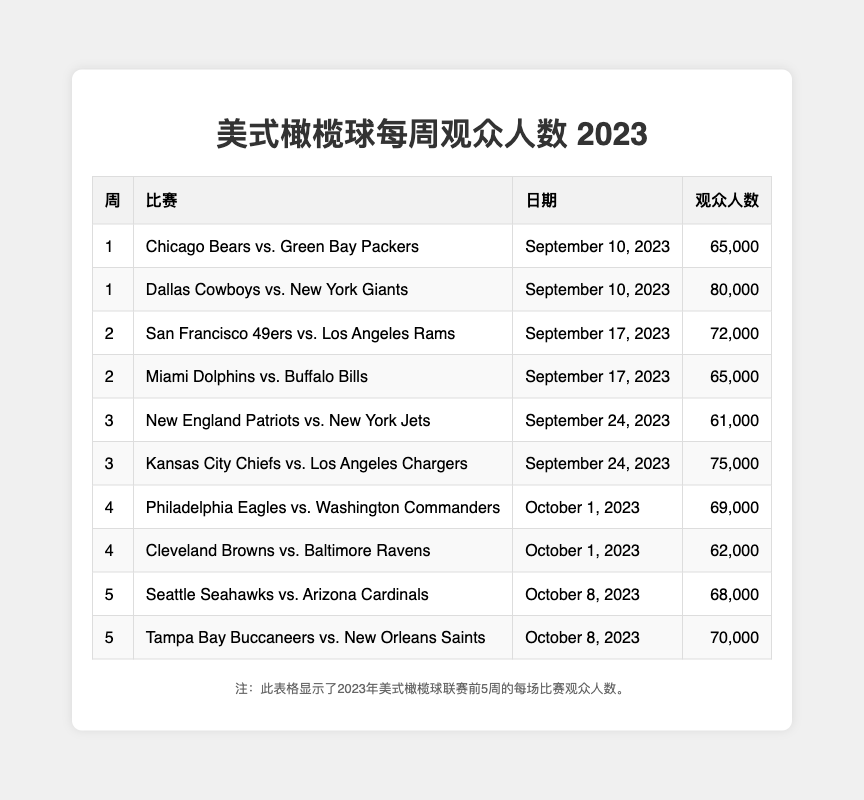What is the attendance for the game between the Chicago Bears and the Green Bay Packers? In the table, the game Chicago Bears vs. Green Bay Packers is listed under week 1, and the attendance figure is explicitly provided as 65,000.
Answer: 65,000 Which game had the highest attendance in week 1? The table indicates that in week 1, there were two games: Chicago Bears vs. Green Bay Packers with 65,000 and Dallas Cowboys vs. New York Giants with 80,000. The Dallas Cowboys game has the higher attendance.
Answer: Dallas Cowboys vs. New York Giants What is the average attendance for week 3 games? Week 3 includes two games: New England Patriots vs. New York Jets with 61,000 and Kansas City Chiefs vs. Los Angeles Chargers with 75,000. The total attendance is 61,000 + 75,000 = 136,000 and there are 2 games, so the average is 136,000 / 2 = 68,000.
Answer: 68,000 How many games had attendance figures above 70,000 in the first five weeks? By reviewing the table, the games with attendance above 70,000 are: Dallas Cowboys vs. New York Giants (80,000), San Francisco 49ers vs. Los Angeles Rams (72,000), Kansas City Chiefs vs. Los Angeles Chargers (75,000), and the game on week 5: Tampa Bay Buccaneers vs. New Orleans Saints (70,000), totaling 4 games.
Answer: 4 What was the total attendance across all games in week 2? In week 2, there are two games: San Francisco 49ers vs. Los Angeles Rams with 72,000 and Miami Dolphins vs. Buffalo Bills with 65,000. Adding these gives us a total attendance of 72,000 + 65,000 = 137,000.
Answer: 137,000 Was the attendance for the game between the Philadelphia Eagles and Washington Commanders higher than 70,000? The attendance listed for the Philadelphia Eagles vs. Washington Commanders in week 4 is 69,000, which is below 70,000. Therefore, the statement is false.
Answer: No Which week had the lowest total attendance? To find the week with the lowest total, we calculate the attendance for each week: Week 1 = 145,000, Week 2 = 137,000, Week 3 = 136,000, Week 4 = 131,000, and Week 5 = 138,000. The lowest total is from week 4 with 131,000.
Answer: Week 4 What is the difference in attendance between the game with the highest attendance and the game with the lowest attendance across the first five weeks? The highest attendance across the games is 80,000 (Dallas Cowboys vs. New York Giants) and the lowest is 61,000 (New England Patriots vs. New York Jets). The difference is 80,000 - 61,000 = 19,000.
Answer: 19,000 